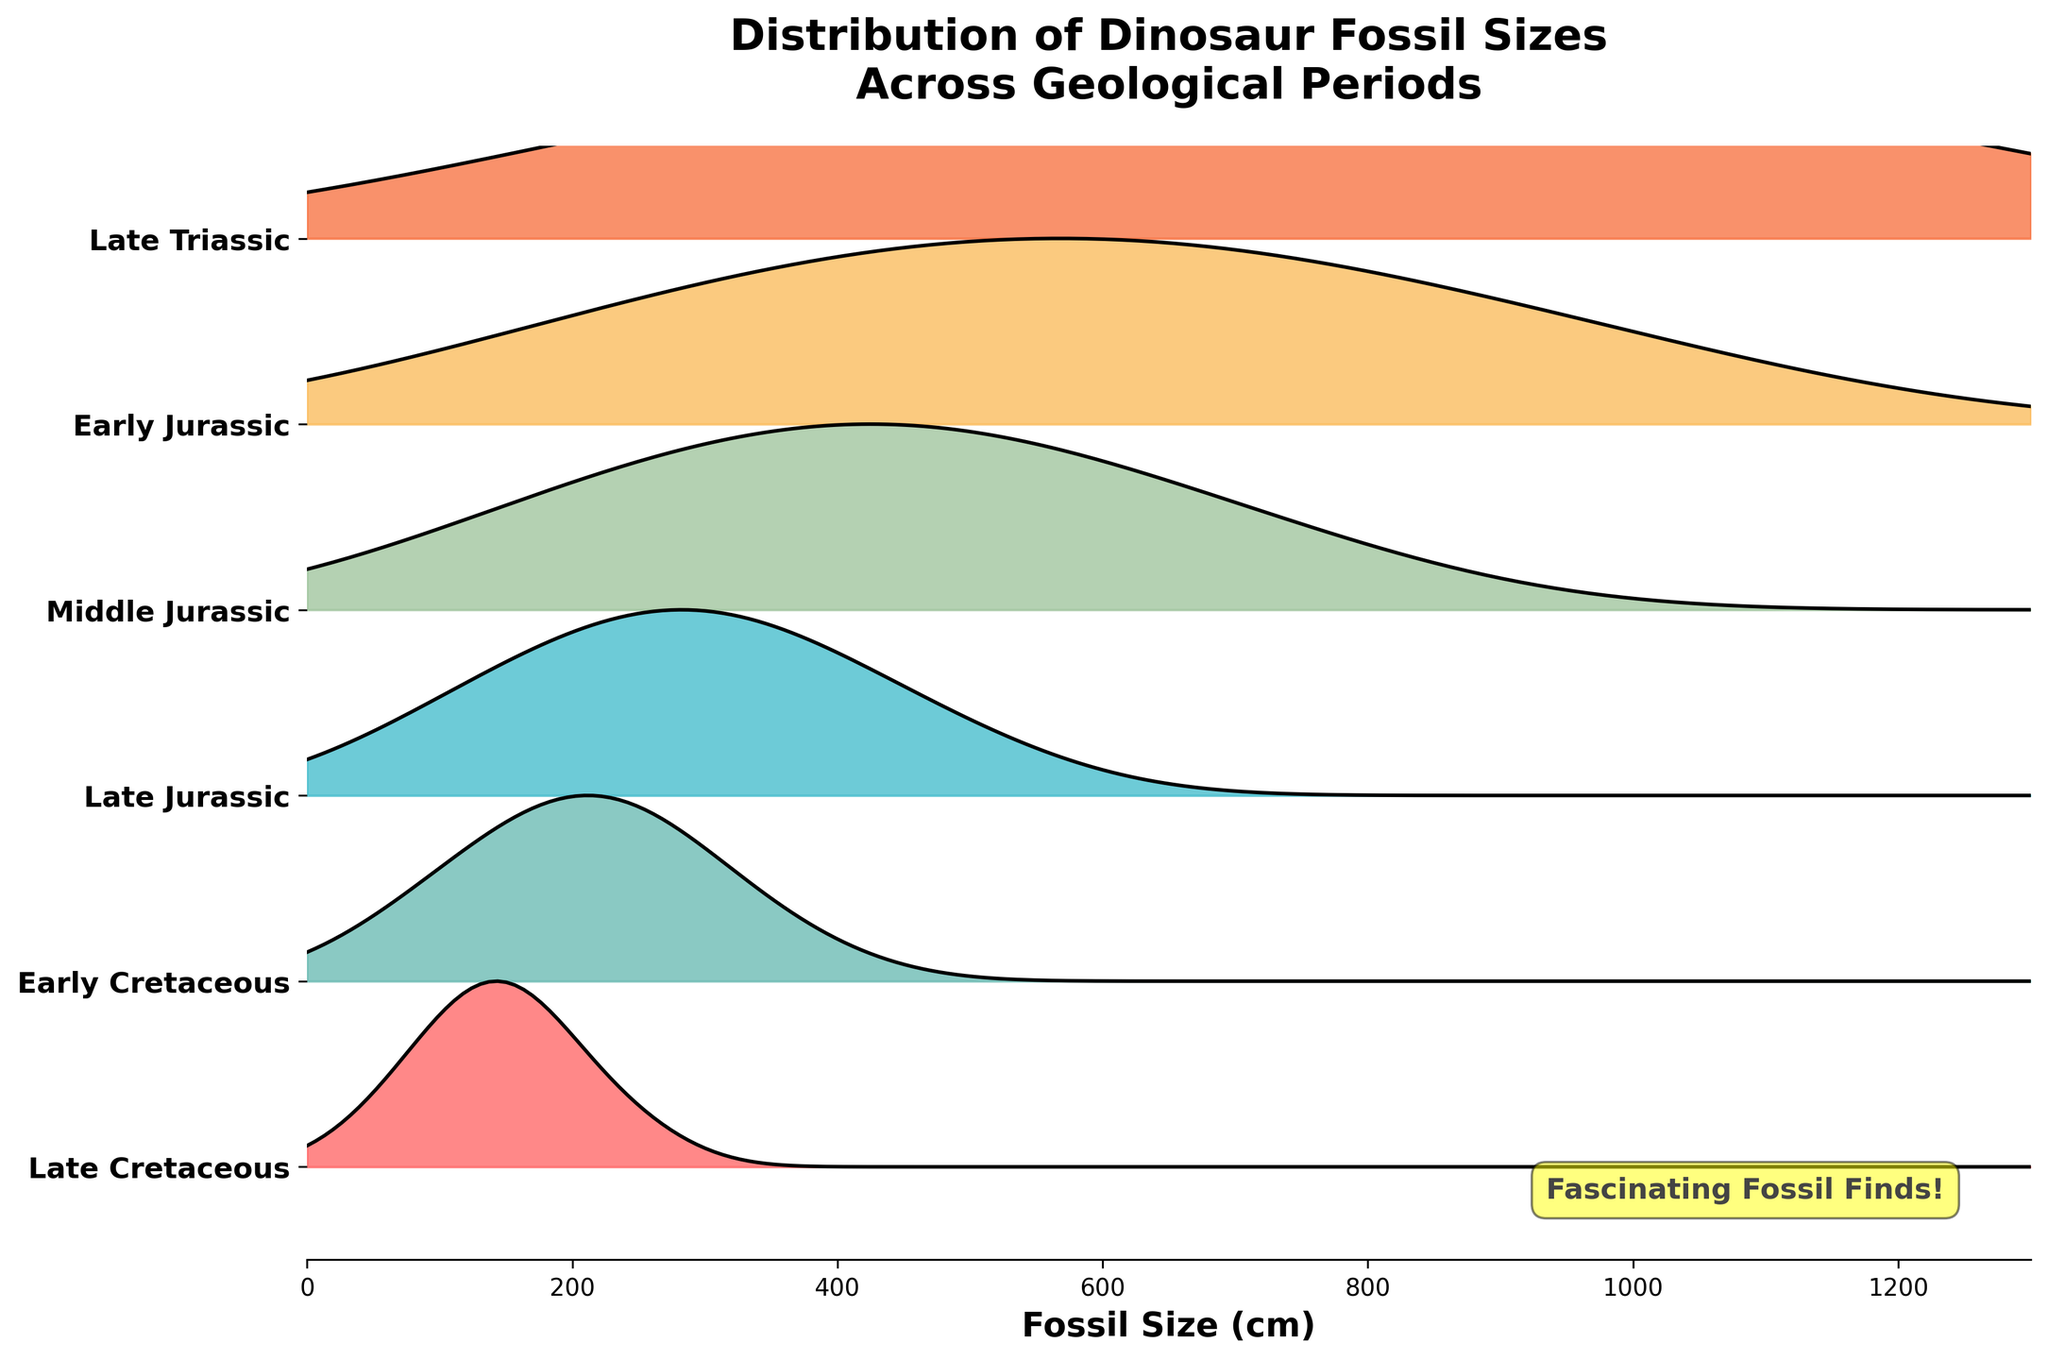What is the title of the Ridgeline plot? The title is displayed at the top of the plot and reads "Distribution of Dinosaur Fossil Sizes Across Geological Periods."
Answer: Distribution of Dinosaur Fossil Sizes Across Geological Periods How many geological periods are displayed in the plot? The y-axis shows the names of all the geological periods included. By counting the distinct labels, we see that there are six geological periods listed.
Answer: Six Which geological period shows the highest density of fossils around the size of 450 cm? Looking at the height of the peaks across the different periods, the Late Jurassic period has the highest density peak around the 450 cm mark.
Answer: Late Jurassic What is the smallest size of fossils observed in the Late Triassic period? By observing the data representation for the Late Triassic period, the smallest size is at the far left of the x-axis for this period, which is 50 cm.
Answer: 50 cm Which geological period has the widest range of fossil sizes? The x-axis spans from the minimum to the maximum sizes within each period. The Late Cretaceous period appears to have fossils ranging from 250 cm to 1250 cm, the widest range displayed.
Answer: Late Cretaceous In which geological period do we observe the highest density at around 1000 cm? By comparing the density peaks around the 1000 cm mark, the Early Cretaceous period has the highest density at this size.
Answer: Early Cretaceous What is the maximum fossil size observed in the Middle Jurassic period? By looking at the rightmost point on the ridgeline for the Middle Jurassic, the largest size is 500 cm.
Answer: 500 cm Between Early Jurassic and Middle Jurassic, which period has a higher peak density? Compare the height of the density peaks between Early Jurassic and Middle Jurassic. The Middle Jurassic period has a higher peak density.
Answer: Middle Jurassic Is there any period where the density falls to zero between 0 cm and 1300 cm? By examining the ridgeline plots, all periods have non-zero densities throughout the span from 0 to 1300 cm, indicated by continuous lines.
Answer: No 